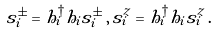<formula> <loc_0><loc_0><loc_500><loc_500>s _ { i } ^ { \pm } = h ^ { \dagger } _ { i } h _ { i } \tilde { s } _ { i } ^ { \pm } \, , \, s _ { i } ^ { z } = h ^ { \dagger } _ { i } h _ { i } \tilde { s } _ { i } ^ { z } \, .</formula> 